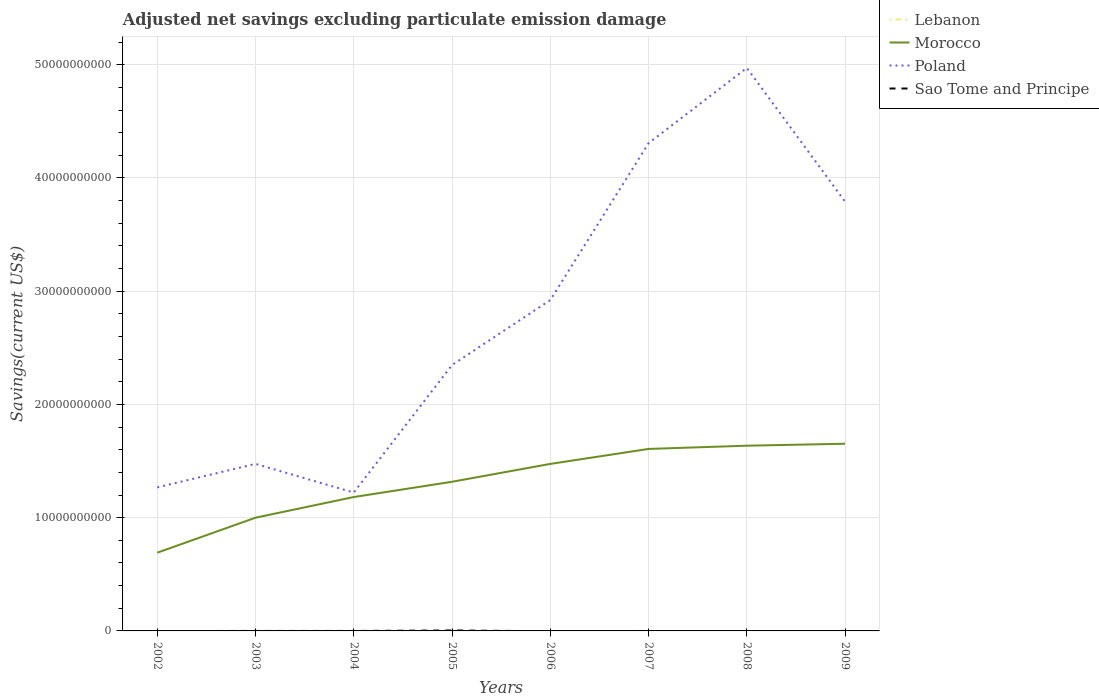How many different coloured lines are there?
Your answer should be compact. 3. Is the number of lines equal to the number of legend labels?
Offer a terse response. No. Across all years, what is the maximum adjusted net savings in Sao Tome and Principe?
Make the answer very short. 0. What is the total adjusted net savings in Morocco in the graph?
Your answer should be very brief. -1.61e+09. What is the difference between the highest and the second highest adjusted net savings in Sao Tome and Principe?
Offer a very short reply. 4.16e+07. What is the difference between the highest and the lowest adjusted net savings in Lebanon?
Offer a very short reply. 0. Is the adjusted net savings in Morocco strictly greater than the adjusted net savings in Lebanon over the years?
Give a very brief answer. No. Does the graph contain any zero values?
Give a very brief answer. Yes. Does the graph contain grids?
Make the answer very short. Yes. How many legend labels are there?
Your answer should be very brief. 4. How are the legend labels stacked?
Provide a short and direct response. Vertical. What is the title of the graph?
Offer a terse response. Adjusted net savings excluding particulate emission damage. Does "Brunei Darussalam" appear as one of the legend labels in the graph?
Your answer should be compact. No. What is the label or title of the X-axis?
Your answer should be very brief. Years. What is the label or title of the Y-axis?
Provide a succinct answer. Savings(current US$). What is the Savings(current US$) of Lebanon in 2002?
Ensure brevity in your answer.  0. What is the Savings(current US$) of Morocco in 2002?
Your answer should be compact. 6.91e+09. What is the Savings(current US$) of Poland in 2002?
Provide a succinct answer. 1.27e+1. What is the Savings(current US$) of Morocco in 2003?
Your answer should be very brief. 1.00e+1. What is the Savings(current US$) in Poland in 2003?
Your answer should be compact. 1.48e+1. What is the Savings(current US$) in Morocco in 2004?
Keep it short and to the point. 1.18e+1. What is the Savings(current US$) of Poland in 2004?
Provide a succinct answer. 1.22e+1. What is the Savings(current US$) in Morocco in 2005?
Keep it short and to the point. 1.32e+1. What is the Savings(current US$) in Poland in 2005?
Give a very brief answer. 2.35e+1. What is the Savings(current US$) in Sao Tome and Principe in 2005?
Your answer should be very brief. 4.16e+07. What is the Savings(current US$) of Morocco in 2006?
Provide a short and direct response. 1.47e+1. What is the Savings(current US$) of Poland in 2006?
Offer a terse response. 2.92e+1. What is the Savings(current US$) of Sao Tome and Principe in 2006?
Offer a very short reply. 0. What is the Savings(current US$) in Morocco in 2007?
Provide a succinct answer. 1.61e+1. What is the Savings(current US$) of Poland in 2007?
Your response must be concise. 4.31e+1. What is the Savings(current US$) of Sao Tome and Principe in 2007?
Your answer should be very brief. 0. What is the Savings(current US$) of Morocco in 2008?
Ensure brevity in your answer.  1.64e+1. What is the Savings(current US$) of Poland in 2008?
Provide a short and direct response. 4.97e+1. What is the Savings(current US$) of Sao Tome and Principe in 2008?
Your response must be concise. 0. What is the Savings(current US$) in Morocco in 2009?
Make the answer very short. 1.65e+1. What is the Savings(current US$) of Poland in 2009?
Give a very brief answer. 3.79e+1. What is the Savings(current US$) of Sao Tome and Principe in 2009?
Provide a short and direct response. 3.99e+05. Across all years, what is the maximum Savings(current US$) of Morocco?
Keep it short and to the point. 1.65e+1. Across all years, what is the maximum Savings(current US$) of Poland?
Your answer should be compact. 4.97e+1. Across all years, what is the maximum Savings(current US$) in Sao Tome and Principe?
Provide a short and direct response. 4.16e+07. Across all years, what is the minimum Savings(current US$) in Morocco?
Offer a terse response. 6.91e+09. Across all years, what is the minimum Savings(current US$) of Poland?
Offer a terse response. 1.22e+1. Across all years, what is the minimum Savings(current US$) in Sao Tome and Principe?
Your answer should be compact. 0. What is the total Savings(current US$) of Morocco in the graph?
Your answer should be compact. 1.06e+11. What is the total Savings(current US$) in Poland in the graph?
Keep it short and to the point. 2.23e+11. What is the total Savings(current US$) in Sao Tome and Principe in the graph?
Keep it short and to the point. 4.20e+07. What is the difference between the Savings(current US$) of Morocco in 2002 and that in 2003?
Your answer should be very brief. -3.09e+09. What is the difference between the Savings(current US$) in Poland in 2002 and that in 2003?
Your answer should be compact. -2.08e+09. What is the difference between the Savings(current US$) of Morocco in 2002 and that in 2004?
Give a very brief answer. -4.92e+09. What is the difference between the Savings(current US$) in Poland in 2002 and that in 2004?
Your answer should be compact. 4.56e+08. What is the difference between the Savings(current US$) in Morocco in 2002 and that in 2005?
Make the answer very short. -6.26e+09. What is the difference between the Savings(current US$) in Poland in 2002 and that in 2005?
Offer a very short reply. -1.08e+1. What is the difference between the Savings(current US$) in Morocco in 2002 and that in 2006?
Your response must be concise. -7.84e+09. What is the difference between the Savings(current US$) in Poland in 2002 and that in 2006?
Ensure brevity in your answer.  -1.65e+1. What is the difference between the Savings(current US$) in Morocco in 2002 and that in 2007?
Ensure brevity in your answer.  -9.16e+09. What is the difference between the Savings(current US$) in Poland in 2002 and that in 2007?
Offer a very short reply. -3.04e+1. What is the difference between the Savings(current US$) of Morocco in 2002 and that in 2008?
Your answer should be very brief. -9.45e+09. What is the difference between the Savings(current US$) in Poland in 2002 and that in 2008?
Your answer should be compact. -3.70e+1. What is the difference between the Savings(current US$) in Morocco in 2002 and that in 2009?
Make the answer very short. -9.62e+09. What is the difference between the Savings(current US$) in Poland in 2002 and that in 2009?
Make the answer very short. -2.52e+1. What is the difference between the Savings(current US$) of Morocco in 2003 and that in 2004?
Offer a very short reply. -1.82e+09. What is the difference between the Savings(current US$) of Poland in 2003 and that in 2004?
Your response must be concise. 2.53e+09. What is the difference between the Savings(current US$) in Morocco in 2003 and that in 2005?
Offer a terse response. -3.17e+09. What is the difference between the Savings(current US$) in Poland in 2003 and that in 2005?
Provide a short and direct response. -8.73e+09. What is the difference between the Savings(current US$) in Morocco in 2003 and that in 2006?
Your response must be concise. -4.75e+09. What is the difference between the Savings(current US$) of Poland in 2003 and that in 2006?
Your answer should be compact. -1.45e+1. What is the difference between the Savings(current US$) in Morocco in 2003 and that in 2007?
Provide a short and direct response. -6.07e+09. What is the difference between the Savings(current US$) of Poland in 2003 and that in 2007?
Your response must be concise. -2.83e+1. What is the difference between the Savings(current US$) in Morocco in 2003 and that in 2008?
Your response must be concise. -6.36e+09. What is the difference between the Savings(current US$) in Poland in 2003 and that in 2008?
Your answer should be compact. -3.50e+1. What is the difference between the Savings(current US$) of Morocco in 2003 and that in 2009?
Your answer should be compact. -6.53e+09. What is the difference between the Savings(current US$) in Poland in 2003 and that in 2009?
Offer a very short reply. -2.32e+1. What is the difference between the Savings(current US$) in Morocco in 2004 and that in 2005?
Keep it short and to the point. -1.35e+09. What is the difference between the Savings(current US$) of Poland in 2004 and that in 2005?
Offer a very short reply. -1.13e+1. What is the difference between the Savings(current US$) of Morocco in 2004 and that in 2006?
Offer a terse response. -2.93e+09. What is the difference between the Savings(current US$) in Poland in 2004 and that in 2006?
Ensure brevity in your answer.  -1.70e+1. What is the difference between the Savings(current US$) of Morocco in 2004 and that in 2007?
Offer a very short reply. -4.25e+09. What is the difference between the Savings(current US$) in Poland in 2004 and that in 2007?
Provide a short and direct response. -3.09e+1. What is the difference between the Savings(current US$) of Morocco in 2004 and that in 2008?
Provide a short and direct response. -4.53e+09. What is the difference between the Savings(current US$) in Poland in 2004 and that in 2008?
Make the answer very short. -3.75e+1. What is the difference between the Savings(current US$) of Morocco in 2004 and that in 2009?
Offer a terse response. -4.71e+09. What is the difference between the Savings(current US$) of Poland in 2004 and that in 2009?
Offer a very short reply. -2.57e+1. What is the difference between the Savings(current US$) of Morocco in 2005 and that in 2006?
Offer a very short reply. -1.58e+09. What is the difference between the Savings(current US$) in Poland in 2005 and that in 2006?
Provide a succinct answer. -5.74e+09. What is the difference between the Savings(current US$) in Morocco in 2005 and that in 2007?
Keep it short and to the point. -2.90e+09. What is the difference between the Savings(current US$) in Poland in 2005 and that in 2007?
Ensure brevity in your answer.  -1.96e+1. What is the difference between the Savings(current US$) of Morocco in 2005 and that in 2008?
Your response must be concise. -3.19e+09. What is the difference between the Savings(current US$) of Poland in 2005 and that in 2008?
Offer a terse response. -2.62e+1. What is the difference between the Savings(current US$) of Morocco in 2005 and that in 2009?
Make the answer very short. -3.36e+09. What is the difference between the Savings(current US$) in Poland in 2005 and that in 2009?
Provide a short and direct response. -1.44e+1. What is the difference between the Savings(current US$) in Sao Tome and Principe in 2005 and that in 2009?
Provide a succinct answer. 4.12e+07. What is the difference between the Savings(current US$) of Morocco in 2006 and that in 2007?
Ensure brevity in your answer.  -1.32e+09. What is the difference between the Savings(current US$) in Poland in 2006 and that in 2007?
Make the answer very short. -1.39e+1. What is the difference between the Savings(current US$) of Morocco in 2006 and that in 2008?
Ensure brevity in your answer.  -1.61e+09. What is the difference between the Savings(current US$) in Poland in 2006 and that in 2008?
Offer a very short reply. -2.05e+1. What is the difference between the Savings(current US$) of Morocco in 2006 and that in 2009?
Your answer should be compact. -1.78e+09. What is the difference between the Savings(current US$) of Poland in 2006 and that in 2009?
Offer a terse response. -8.69e+09. What is the difference between the Savings(current US$) of Morocco in 2007 and that in 2008?
Make the answer very short. -2.86e+08. What is the difference between the Savings(current US$) of Poland in 2007 and that in 2008?
Provide a short and direct response. -6.64e+09. What is the difference between the Savings(current US$) of Morocco in 2007 and that in 2009?
Offer a very short reply. -4.58e+08. What is the difference between the Savings(current US$) in Poland in 2007 and that in 2009?
Make the answer very short. 5.17e+09. What is the difference between the Savings(current US$) of Morocco in 2008 and that in 2009?
Your answer should be very brief. -1.73e+08. What is the difference between the Savings(current US$) in Poland in 2008 and that in 2009?
Provide a succinct answer. 1.18e+1. What is the difference between the Savings(current US$) in Morocco in 2002 and the Savings(current US$) in Poland in 2003?
Ensure brevity in your answer.  -7.84e+09. What is the difference between the Savings(current US$) in Morocco in 2002 and the Savings(current US$) in Poland in 2004?
Make the answer very short. -5.31e+09. What is the difference between the Savings(current US$) of Morocco in 2002 and the Savings(current US$) of Poland in 2005?
Your answer should be very brief. -1.66e+1. What is the difference between the Savings(current US$) of Morocco in 2002 and the Savings(current US$) of Sao Tome and Principe in 2005?
Your answer should be very brief. 6.87e+09. What is the difference between the Savings(current US$) of Poland in 2002 and the Savings(current US$) of Sao Tome and Principe in 2005?
Provide a succinct answer. 1.26e+1. What is the difference between the Savings(current US$) in Morocco in 2002 and the Savings(current US$) in Poland in 2006?
Ensure brevity in your answer.  -2.23e+1. What is the difference between the Savings(current US$) in Morocco in 2002 and the Savings(current US$) in Poland in 2007?
Offer a very short reply. -3.62e+1. What is the difference between the Savings(current US$) of Morocco in 2002 and the Savings(current US$) of Poland in 2008?
Provide a short and direct response. -4.28e+1. What is the difference between the Savings(current US$) in Morocco in 2002 and the Savings(current US$) in Poland in 2009?
Provide a short and direct response. -3.10e+1. What is the difference between the Savings(current US$) of Morocco in 2002 and the Savings(current US$) of Sao Tome and Principe in 2009?
Ensure brevity in your answer.  6.91e+09. What is the difference between the Savings(current US$) of Poland in 2002 and the Savings(current US$) of Sao Tome and Principe in 2009?
Provide a short and direct response. 1.27e+1. What is the difference between the Savings(current US$) of Morocco in 2003 and the Savings(current US$) of Poland in 2004?
Keep it short and to the point. -2.22e+09. What is the difference between the Savings(current US$) in Morocco in 2003 and the Savings(current US$) in Poland in 2005?
Offer a terse response. -1.35e+1. What is the difference between the Savings(current US$) of Morocco in 2003 and the Savings(current US$) of Sao Tome and Principe in 2005?
Provide a succinct answer. 9.96e+09. What is the difference between the Savings(current US$) in Poland in 2003 and the Savings(current US$) in Sao Tome and Principe in 2005?
Your answer should be very brief. 1.47e+1. What is the difference between the Savings(current US$) in Morocco in 2003 and the Savings(current US$) in Poland in 2006?
Your response must be concise. -1.92e+1. What is the difference between the Savings(current US$) of Morocco in 2003 and the Savings(current US$) of Poland in 2007?
Provide a succinct answer. -3.31e+1. What is the difference between the Savings(current US$) of Morocco in 2003 and the Savings(current US$) of Poland in 2008?
Your answer should be very brief. -3.97e+1. What is the difference between the Savings(current US$) of Morocco in 2003 and the Savings(current US$) of Poland in 2009?
Keep it short and to the point. -2.79e+1. What is the difference between the Savings(current US$) in Morocco in 2003 and the Savings(current US$) in Sao Tome and Principe in 2009?
Your answer should be compact. 1.00e+1. What is the difference between the Savings(current US$) in Poland in 2003 and the Savings(current US$) in Sao Tome and Principe in 2009?
Offer a very short reply. 1.48e+1. What is the difference between the Savings(current US$) of Morocco in 2004 and the Savings(current US$) of Poland in 2005?
Keep it short and to the point. -1.17e+1. What is the difference between the Savings(current US$) in Morocco in 2004 and the Savings(current US$) in Sao Tome and Principe in 2005?
Make the answer very short. 1.18e+1. What is the difference between the Savings(current US$) in Poland in 2004 and the Savings(current US$) in Sao Tome and Principe in 2005?
Offer a very short reply. 1.22e+1. What is the difference between the Savings(current US$) in Morocco in 2004 and the Savings(current US$) in Poland in 2006?
Your answer should be very brief. -1.74e+1. What is the difference between the Savings(current US$) of Morocco in 2004 and the Savings(current US$) of Poland in 2007?
Your response must be concise. -3.13e+1. What is the difference between the Savings(current US$) of Morocco in 2004 and the Savings(current US$) of Poland in 2008?
Provide a succinct answer. -3.79e+1. What is the difference between the Savings(current US$) in Morocco in 2004 and the Savings(current US$) in Poland in 2009?
Offer a terse response. -2.61e+1. What is the difference between the Savings(current US$) of Morocco in 2004 and the Savings(current US$) of Sao Tome and Principe in 2009?
Offer a very short reply. 1.18e+1. What is the difference between the Savings(current US$) in Poland in 2004 and the Savings(current US$) in Sao Tome and Principe in 2009?
Offer a terse response. 1.22e+1. What is the difference between the Savings(current US$) in Morocco in 2005 and the Savings(current US$) in Poland in 2006?
Give a very brief answer. -1.60e+1. What is the difference between the Savings(current US$) of Morocco in 2005 and the Savings(current US$) of Poland in 2007?
Make the answer very short. -2.99e+1. What is the difference between the Savings(current US$) in Morocco in 2005 and the Savings(current US$) in Poland in 2008?
Provide a short and direct response. -3.65e+1. What is the difference between the Savings(current US$) in Morocco in 2005 and the Savings(current US$) in Poland in 2009?
Provide a short and direct response. -2.47e+1. What is the difference between the Savings(current US$) of Morocco in 2005 and the Savings(current US$) of Sao Tome and Principe in 2009?
Make the answer very short. 1.32e+1. What is the difference between the Savings(current US$) in Poland in 2005 and the Savings(current US$) in Sao Tome and Principe in 2009?
Your answer should be very brief. 2.35e+1. What is the difference between the Savings(current US$) of Morocco in 2006 and the Savings(current US$) of Poland in 2007?
Your response must be concise. -2.83e+1. What is the difference between the Savings(current US$) of Morocco in 2006 and the Savings(current US$) of Poland in 2008?
Your answer should be very brief. -3.50e+1. What is the difference between the Savings(current US$) in Morocco in 2006 and the Savings(current US$) in Poland in 2009?
Your answer should be compact. -2.32e+1. What is the difference between the Savings(current US$) in Morocco in 2006 and the Savings(current US$) in Sao Tome and Principe in 2009?
Make the answer very short. 1.47e+1. What is the difference between the Savings(current US$) in Poland in 2006 and the Savings(current US$) in Sao Tome and Principe in 2009?
Ensure brevity in your answer.  2.92e+1. What is the difference between the Savings(current US$) in Morocco in 2007 and the Savings(current US$) in Poland in 2008?
Provide a short and direct response. -3.36e+1. What is the difference between the Savings(current US$) of Morocco in 2007 and the Savings(current US$) of Poland in 2009?
Keep it short and to the point. -2.18e+1. What is the difference between the Savings(current US$) in Morocco in 2007 and the Savings(current US$) in Sao Tome and Principe in 2009?
Keep it short and to the point. 1.61e+1. What is the difference between the Savings(current US$) of Poland in 2007 and the Savings(current US$) of Sao Tome and Principe in 2009?
Your answer should be compact. 4.31e+1. What is the difference between the Savings(current US$) of Morocco in 2008 and the Savings(current US$) of Poland in 2009?
Give a very brief answer. -2.16e+1. What is the difference between the Savings(current US$) of Morocco in 2008 and the Savings(current US$) of Sao Tome and Principe in 2009?
Your response must be concise. 1.64e+1. What is the difference between the Savings(current US$) in Poland in 2008 and the Savings(current US$) in Sao Tome and Principe in 2009?
Offer a very short reply. 4.97e+1. What is the average Savings(current US$) in Morocco per year?
Make the answer very short. 1.32e+1. What is the average Savings(current US$) in Poland per year?
Offer a terse response. 2.79e+1. What is the average Savings(current US$) of Sao Tome and Principe per year?
Your answer should be compact. 5.25e+06. In the year 2002, what is the difference between the Savings(current US$) of Morocco and Savings(current US$) of Poland?
Your answer should be compact. -5.77e+09. In the year 2003, what is the difference between the Savings(current US$) in Morocco and Savings(current US$) in Poland?
Give a very brief answer. -4.75e+09. In the year 2004, what is the difference between the Savings(current US$) in Morocco and Savings(current US$) in Poland?
Your answer should be very brief. -3.97e+08. In the year 2005, what is the difference between the Savings(current US$) of Morocco and Savings(current US$) of Poland?
Keep it short and to the point. -1.03e+1. In the year 2005, what is the difference between the Savings(current US$) of Morocco and Savings(current US$) of Sao Tome and Principe?
Offer a terse response. 1.31e+1. In the year 2005, what is the difference between the Savings(current US$) of Poland and Savings(current US$) of Sao Tome and Principe?
Provide a short and direct response. 2.34e+1. In the year 2006, what is the difference between the Savings(current US$) of Morocco and Savings(current US$) of Poland?
Ensure brevity in your answer.  -1.45e+1. In the year 2007, what is the difference between the Savings(current US$) of Morocco and Savings(current US$) of Poland?
Give a very brief answer. -2.70e+1. In the year 2008, what is the difference between the Savings(current US$) of Morocco and Savings(current US$) of Poland?
Your answer should be very brief. -3.34e+1. In the year 2009, what is the difference between the Savings(current US$) in Morocco and Savings(current US$) in Poland?
Your answer should be compact. -2.14e+1. In the year 2009, what is the difference between the Savings(current US$) in Morocco and Savings(current US$) in Sao Tome and Principe?
Offer a very short reply. 1.65e+1. In the year 2009, what is the difference between the Savings(current US$) in Poland and Savings(current US$) in Sao Tome and Principe?
Your answer should be compact. 3.79e+1. What is the ratio of the Savings(current US$) of Morocco in 2002 to that in 2003?
Give a very brief answer. 0.69. What is the ratio of the Savings(current US$) in Poland in 2002 to that in 2003?
Make the answer very short. 0.86. What is the ratio of the Savings(current US$) in Morocco in 2002 to that in 2004?
Your answer should be compact. 0.58. What is the ratio of the Savings(current US$) of Poland in 2002 to that in 2004?
Provide a succinct answer. 1.04. What is the ratio of the Savings(current US$) in Morocco in 2002 to that in 2005?
Ensure brevity in your answer.  0.52. What is the ratio of the Savings(current US$) of Poland in 2002 to that in 2005?
Your answer should be compact. 0.54. What is the ratio of the Savings(current US$) of Morocco in 2002 to that in 2006?
Ensure brevity in your answer.  0.47. What is the ratio of the Savings(current US$) of Poland in 2002 to that in 2006?
Offer a terse response. 0.43. What is the ratio of the Savings(current US$) in Morocco in 2002 to that in 2007?
Provide a short and direct response. 0.43. What is the ratio of the Savings(current US$) of Poland in 2002 to that in 2007?
Give a very brief answer. 0.29. What is the ratio of the Savings(current US$) of Morocco in 2002 to that in 2008?
Give a very brief answer. 0.42. What is the ratio of the Savings(current US$) in Poland in 2002 to that in 2008?
Your answer should be compact. 0.26. What is the ratio of the Savings(current US$) of Morocco in 2002 to that in 2009?
Make the answer very short. 0.42. What is the ratio of the Savings(current US$) of Poland in 2002 to that in 2009?
Provide a succinct answer. 0.33. What is the ratio of the Savings(current US$) of Morocco in 2003 to that in 2004?
Ensure brevity in your answer.  0.85. What is the ratio of the Savings(current US$) in Poland in 2003 to that in 2004?
Provide a succinct answer. 1.21. What is the ratio of the Savings(current US$) of Morocco in 2003 to that in 2005?
Your answer should be very brief. 0.76. What is the ratio of the Savings(current US$) of Poland in 2003 to that in 2005?
Ensure brevity in your answer.  0.63. What is the ratio of the Savings(current US$) of Morocco in 2003 to that in 2006?
Your answer should be compact. 0.68. What is the ratio of the Savings(current US$) of Poland in 2003 to that in 2006?
Your response must be concise. 0.5. What is the ratio of the Savings(current US$) of Morocco in 2003 to that in 2007?
Ensure brevity in your answer.  0.62. What is the ratio of the Savings(current US$) of Poland in 2003 to that in 2007?
Provide a succinct answer. 0.34. What is the ratio of the Savings(current US$) of Morocco in 2003 to that in 2008?
Your answer should be very brief. 0.61. What is the ratio of the Savings(current US$) in Poland in 2003 to that in 2008?
Offer a very short reply. 0.3. What is the ratio of the Savings(current US$) of Morocco in 2003 to that in 2009?
Provide a succinct answer. 0.6. What is the ratio of the Savings(current US$) of Poland in 2003 to that in 2009?
Offer a very short reply. 0.39. What is the ratio of the Savings(current US$) of Morocco in 2004 to that in 2005?
Keep it short and to the point. 0.9. What is the ratio of the Savings(current US$) in Poland in 2004 to that in 2005?
Offer a very short reply. 0.52. What is the ratio of the Savings(current US$) in Morocco in 2004 to that in 2006?
Your response must be concise. 0.8. What is the ratio of the Savings(current US$) in Poland in 2004 to that in 2006?
Provide a short and direct response. 0.42. What is the ratio of the Savings(current US$) in Morocco in 2004 to that in 2007?
Your answer should be very brief. 0.74. What is the ratio of the Savings(current US$) of Poland in 2004 to that in 2007?
Offer a terse response. 0.28. What is the ratio of the Savings(current US$) in Morocco in 2004 to that in 2008?
Your answer should be very brief. 0.72. What is the ratio of the Savings(current US$) of Poland in 2004 to that in 2008?
Provide a short and direct response. 0.25. What is the ratio of the Savings(current US$) of Morocco in 2004 to that in 2009?
Provide a succinct answer. 0.72. What is the ratio of the Savings(current US$) in Poland in 2004 to that in 2009?
Give a very brief answer. 0.32. What is the ratio of the Savings(current US$) in Morocco in 2005 to that in 2006?
Make the answer very short. 0.89. What is the ratio of the Savings(current US$) of Poland in 2005 to that in 2006?
Give a very brief answer. 0.8. What is the ratio of the Savings(current US$) in Morocco in 2005 to that in 2007?
Give a very brief answer. 0.82. What is the ratio of the Savings(current US$) in Poland in 2005 to that in 2007?
Offer a terse response. 0.55. What is the ratio of the Savings(current US$) in Morocco in 2005 to that in 2008?
Your answer should be compact. 0.81. What is the ratio of the Savings(current US$) in Poland in 2005 to that in 2008?
Your answer should be very brief. 0.47. What is the ratio of the Savings(current US$) in Morocco in 2005 to that in 2009?
Give a very brief answer. 0.8. What is the ratio of the Savings(current US$) of Poland in 2005 to that in 2009?
Make the answer very short. 0.62. What is the ratio of the Savings(current US$) in Sao Tome and Principe in 2005 to that in 2009?
Provide a succinct answer. 104.22. What is the ratio of the Savings(current US$) of Morocco in 2006 to that in 2007?
Your response must be concise. 0.92. What is the ratio of the Savings(current US$) in Poland in 2006 to that in 2007?
Your answer should be compact. 0.68. What is the ratio of the Savings(current US$) of Morocco in 2006 to that in 2008?
Keep it short and to the point. 0.9. What is the ratio of the Savings(current US$) of Poland in 2006 to that in 2008?
Offer a terse response. 0.59. What is the ratio of the Savings(current US$) of Morocco in 2006 to that in 2009?
Provide a short and direct response. 0.89. What is the ratio of the Savings(current US$) of Poland in 2006 to that in 2009?
Provide a short and direct response. 0.77. What is the ratio of the Savings(current US$) in Morocco in 2007 to that in 2008?
Your answer should be compact. 0.98. What is the ratio of the Savings(current US$) of Poland in 2007 to that in 2008?
Offer a very short reply. 0.87. What is the ratio of the Savings(current US$) in Morocco in 2007 to that in 2009?
Keep it short and to the point. 0.97. What is the ratio of the Savings(current US$) in Poland in 2007 to that in 2009?
Ensure brevity in your answer.  1.14. What is the ratio of the Savings(current US$) of Poland in 2008 to that in 2009?
Make the answer very short. 1.31. What is the difference between the highest and the second highest Savings(current US$) in Morocco?
Provide a short and direct response. 1.73e+08. What is the difference between the highest and the second highest Savings(current US$) of Poland?
Offer a very short reply. 6.64e+09. What is the difference between the highest and the lowest Savings(current US$) of Morocco?
Your answer should be very brief. 9.62e+09. What is the difference between the highest and the lowest Savings(current US$) in Poland?
Make the answer very short. 3.75e+1. What is the difference between the highest and the lowest Savings(current US$) of Sao Tome and Principe?
Offer a terse response. 4.16e+07. 